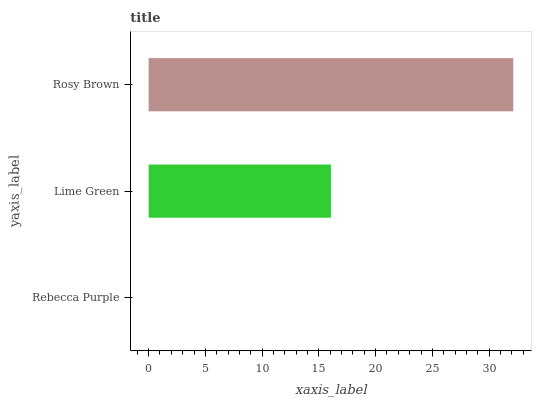Is Rebecca Purple the minimum?
Answer yes or no. Yes. Is Rosy Brown the maximum?
Answer yes or no. Yes. Is Lime Green the minimum?
Answer yes or no. No. Is Lime Green the maximum?
Answer yes or no. No. Is Lime Green greater than Rebecca Purple?
Answer yes or no. Yes. Is Rebecca Purple less than Lime Green?
Answer yes or no. Yes. Is Rebecca Purple greater than Lime Green?
Answer yes or no. No. Is Lime Green less than Rebecca Purple?
Answer yes or no. No. Is Lime Green the high median?
Answer yes or no. Yes. Is Lime Green the low median?
Answer yes or no. Yes. Is Rebecca Purple the high median?
Answer yes or no. No. Is Rebecca Purple the low median?
Answer yes or no. No. 